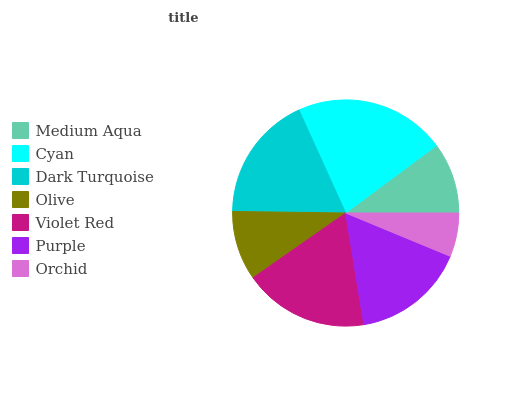Is Orchid the minimum?
Answer yes or no. Yes. Is Cyan the maximum?
Answer yes or no. Yes. Is Dark Turquoise the minimum?
Answer yes or no. No. Is Dark Turquoise the maximum?
Answer yes or no. No. Is Cyan greater than Dark Turquoise?
Answer yes or no. Yes. Is Dark Turquoise less than Cyan?
Answer yes or no. Yes. Is Dark Turquoise greater than Cyan?
Answer yes or no. No. Is Cyan less than Dark Turquoise?
Answer yes or no. No. Is Purple the high median?
Answer yes or no. Yes. Is Purple the low median?
Answer yes or no. Yes. Is Cyan the high median?
Answer yes or no. No. Is Dark Turquoise the low median?
Answer yes or no. No. 